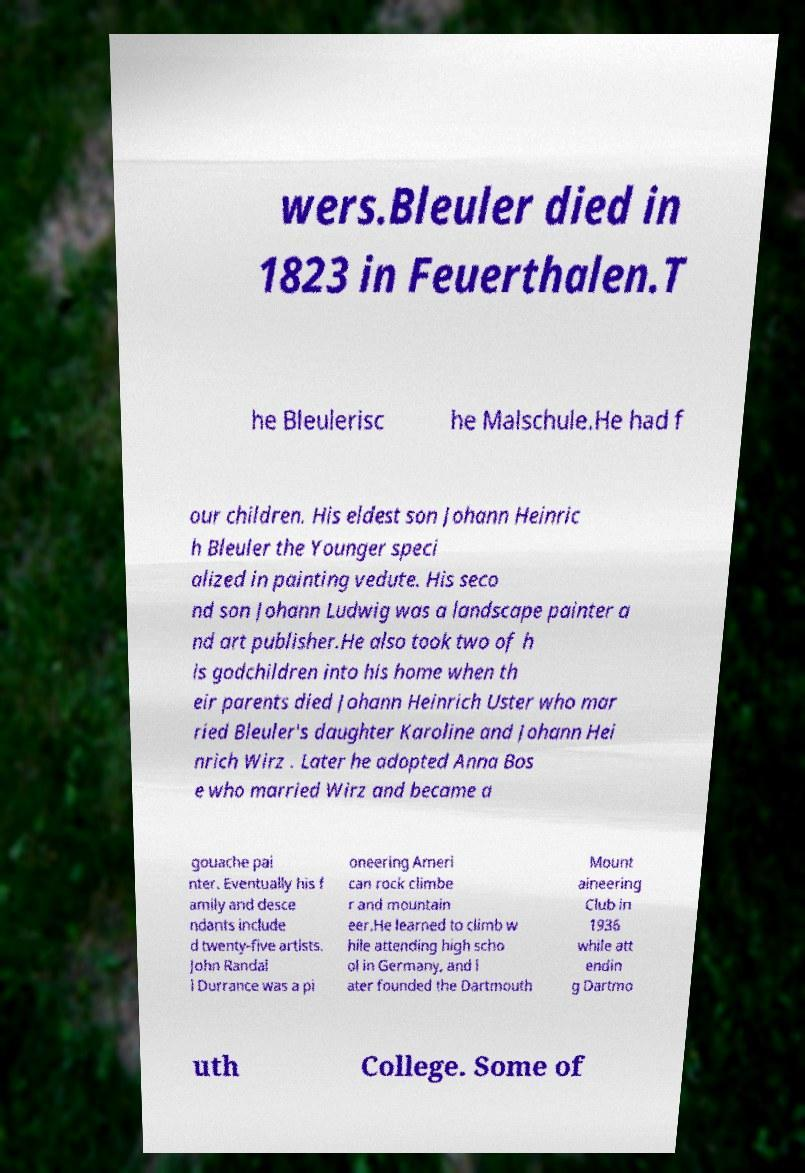Could you extract and type out the text from this image? wers.Bleuler died in 1823 in Feuerthalen.T he Bleulerisc he Malschule.He had f our children. His eldest son Johann Heinric h Bleuler the Younger speci alized in painting vedute. His seco nd son Johann Ludwig was a landscape painter a nd art publisher.He also took two of h is godchildren into his home when th eir parents died Johann Heinrich Uster who mar ried Bleuler's daughter Karoline and Johann Hei nrich Wirz . Later he adopted Anna Bos e who married Wirz and became a gouache pai nter. Eventually his f amily and desce ndants include d twenty-five artists. John Randal l Durrance was a pi oneering Ameri can rock climbe r and mountain eer.He learned to climb w hile attending high scho ol in Germany, and l ater founded the Dartmouth Mount aineering Club in 1936 while att endin g Dartmo uth College. Some of 